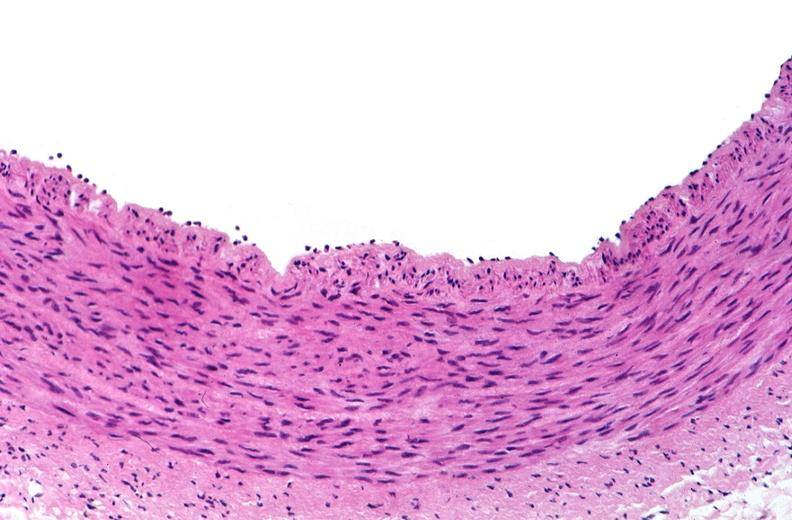what is present?
Answer the question using a single word or phrase. Cardiovascular 